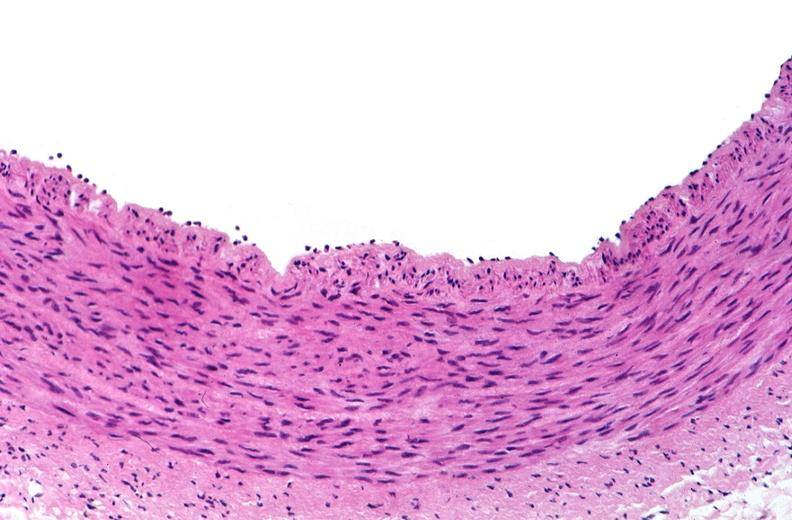what is present?
Answer the question using a single word or phrase. Cardiovascular 